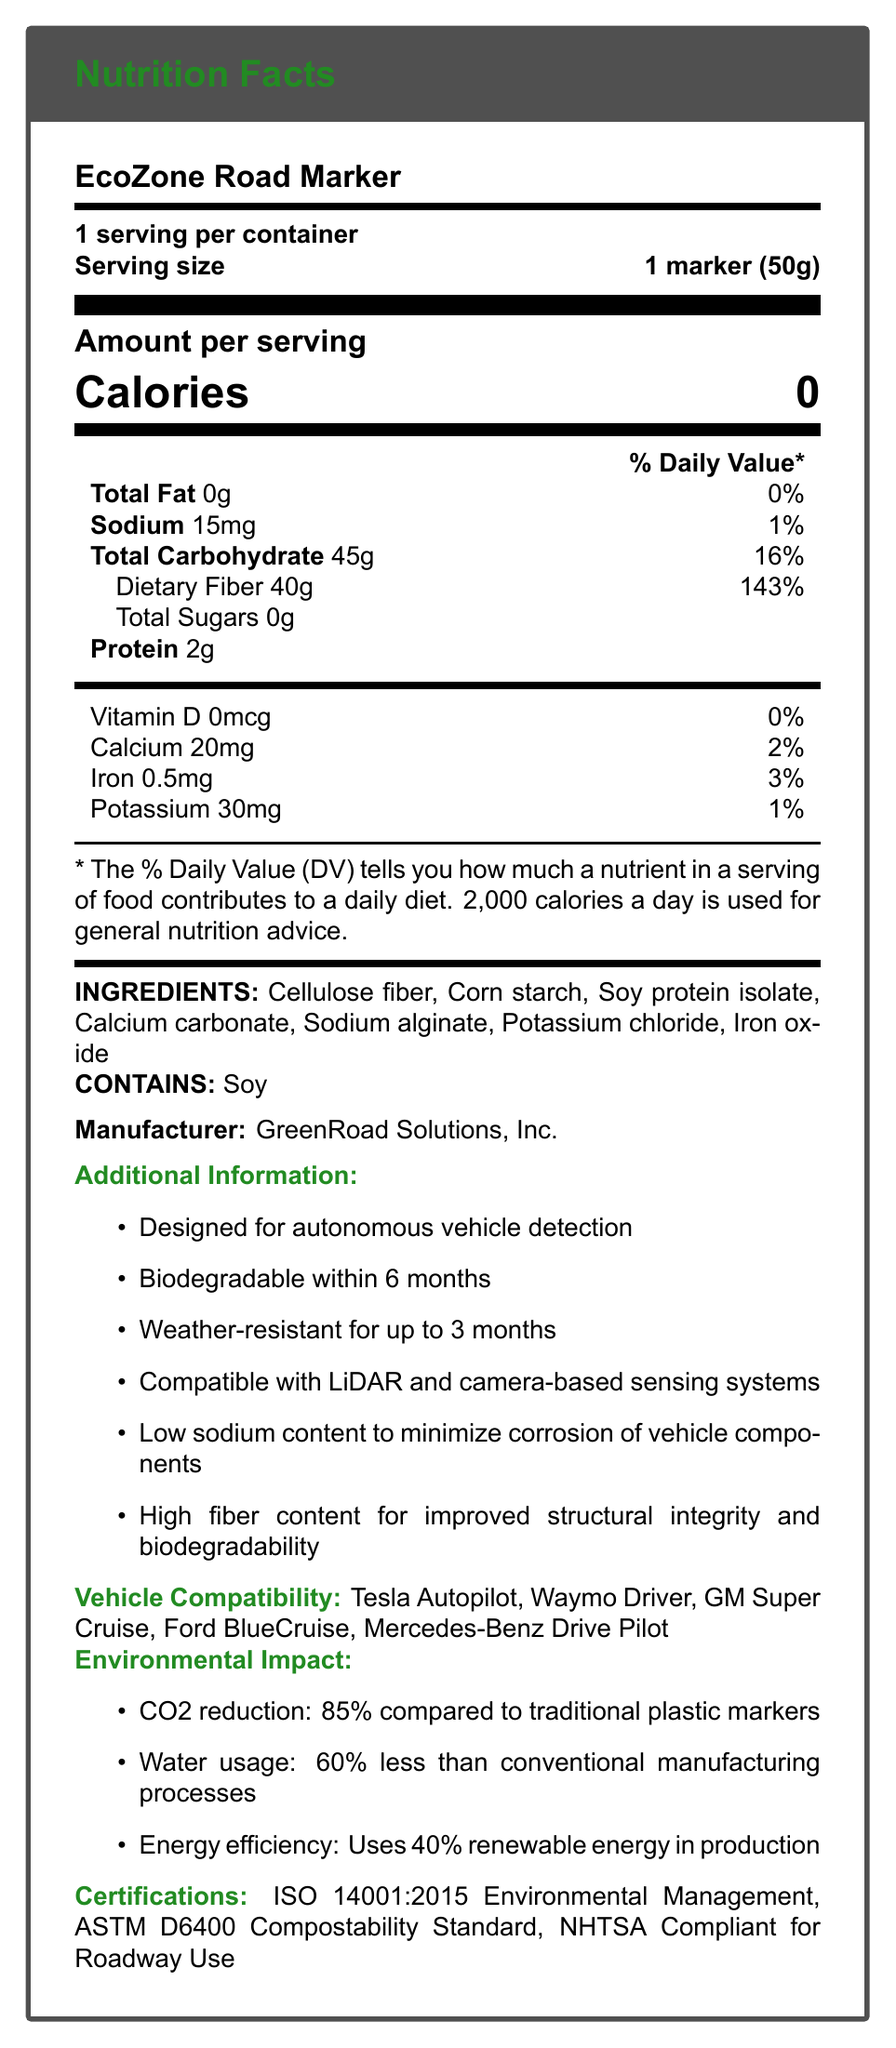what is the serving size for EcoZone Road Marker? The document states the serving size as "1 marker (50g)"
Answer: 1 marker (50g) how much sodium is in one serving of the EcoZone Road Marker? Under the "Sodium" section, it indicates the amount is 15mg.
Answer: 15mg what percentage of the daily value is the dietary fiber in one serving? The dietary fiber amount listed is 40g, which is labeled as 143% Daily Value.
Answer: 143% how many calories are in one serving of EcoZone Road Marker? The document clearly states that there are 0 calories per serving.
Answer: 0 calories who is the manufacturer of the EcoZone Road Marker? The manufacturer's information at the bottom states "GreenRoad Solutions, Inc."
Answer: GreenRoad Solutions, Inc. how long does it take for the EcoZone Road Marker to biodegrade? One of the additional information points mentions that it is "Biodegradable within 6 months."
Answer: within 6 months which nutrient listed has the highest daily value percentage? A. Sodium B. Dietary Fiber C. Protein D. Iron Dietary Fiber has a 143% daily value, which is the highest among the listed nutrients.
Answer: B which certification is NOT held by the EcoZone Road Marker? A. ISO 14001:2015 B. ASTM D6400 C. FDA Approved D. NHTSA Compliant The document lists ISO 14001:2015, ASTM D6400, and NHTSA Compliance, but not FDA approval.
Answer: C is the EcoZone Road Marker compatible with Tesla Autopilot? The vehicle compatibility section includes Tesla Autopilot.
Answer: Yes which ingredient contributes to potential allergens? The allergen information states that the product contains soy.
Answer: Soy protein isolate summarize the main idea of the EcoZone Road Marker document. The document provides detailed information about the nutritional content, ingredients, environmental benefits, vehicle compatibility, and certifications of the EcoZone Road Marker.
Answer: The EcoZone Road Marker is a biodegradable, eco-friendly road marker designed for autonomous vehicle detection. It has high dietary fiber for structural integrity, low sodium to minimize vehicle component corrosion, and is compatible with various vehicle sensing systems. The manufacturer is GreenRoad Solutions, Inc., and the marker holds multiple environmental and safety certifications. what is the total carbohydrate content per serving? The document lists the total carbohydrate content as 45g per serving.
Answer: 45g is there any calcium in the EcoZone Road Marker? The document shows that there is 20mg of calcium per serving.
Answer: Yes how much iron does one serving of the EcoZone Road Marker contain? The document lists the iron content as 0.5mg per serving with a 3% daily value.
Answer: 0.5mg what forms of autonomy compatibility are listed? This information is listed under the vehicle compatibility section.
Answer: Tesla Autopilot, Waymo Driver, GM Super Cruise, Ford BlueCruise, Mercedes-Benz Drive Pilot what is the water usage reduction percentage compared to conventional manufacturing processes? Under the environmental impact section, water usage is shown to be 60% less.
Answer: 60% how does the sodium content contribute to vehicle safety? The additional information section states that low sodium content minimizes corrosion of vehicle components.
Answer: Low sodium content to minimize corrosion of vehicle components. is the EcoZone Road Marker resistant to weather conditions, and if so, for how long? The additional information indicates that the marker is weather-resistant for up to 3 months.
Answer: Yes, up to 3 months what is the potassium content per serving and its daily value percentage? The document shows that one serving contains 30mg of potassium, which is 1% of the daily value.
Answer: 30mg, 1% could the energy usage during production of EcoZone Road Marker be determined from the document? The document only states that 40% renewable energy is used in the production, but it does not provide specific energy consumption figures.
Answer: No, the specific energy usage amount cannot be determined from the document. 